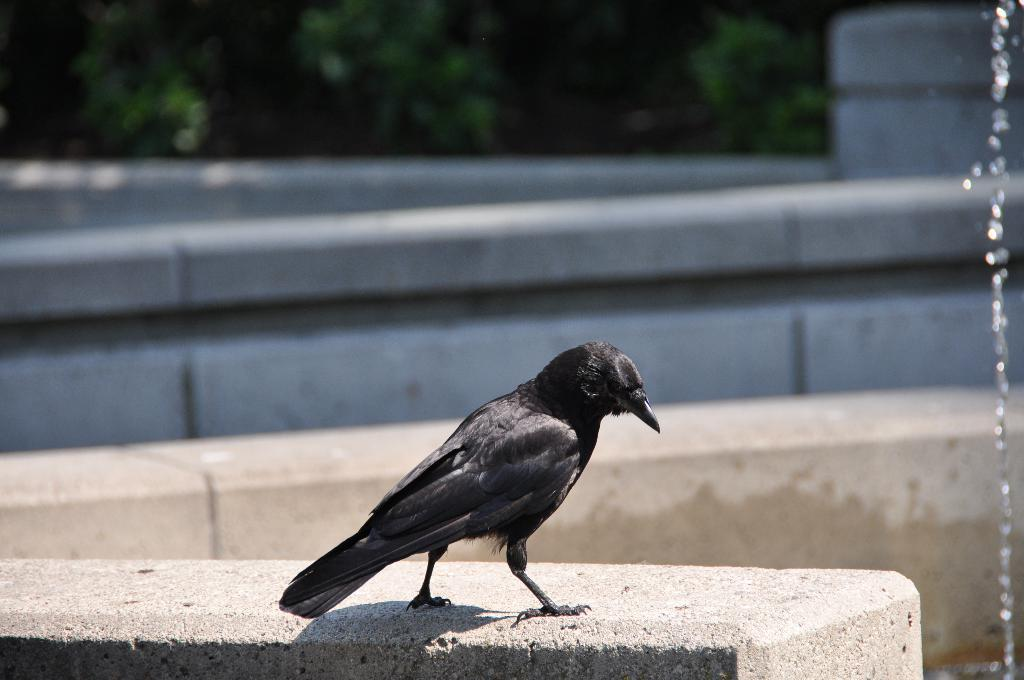What type of bird is on the wall in the image? There is a black color bird on the wall in the image. How would you describe the background of the image? The background of the image is blurred. What can be seen in the blurred background? The blurred background includes a wall and trees. What else is present in the image? Water droplets are present in the image. What type of metal is the tramp using to perform tricks in the image? There is no tramp or metal present in the image; it features a black color bird on a wall with a blurred background and water droplets. 